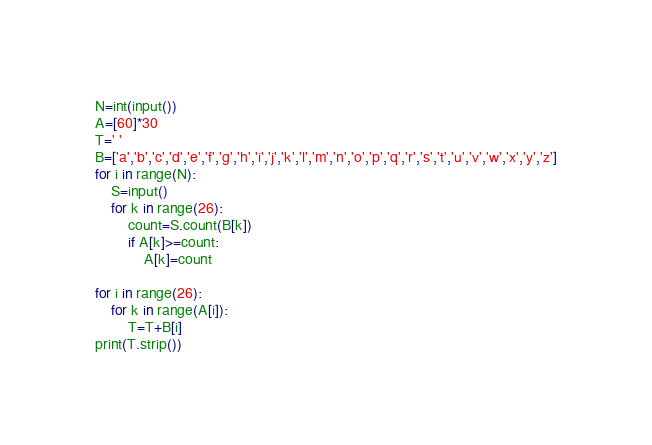Convert code to text. <code><loc_0><loc_0><loc_500><loc_500><_Python_>N=int(input())
A=[60]*30
T=' '
B=['a','b','c','d','e','f','g','h','i','j','k','l','m','n','o','p','q','r','s','t','u','v','w','x','y','z']
for i in range(N):
    S=input()
    for k in range(26):
        count=S.count(B[k])
        if A[k]>=count:
            A[k]=count

for i in range(26):
    for k in range(A[i]):
        T=T+B[i]
print(T.strip())</code> 